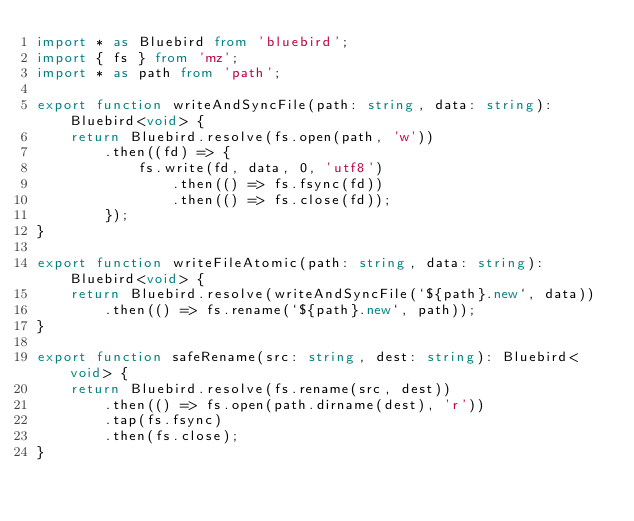Convert code to text. <code><loc_0><loc_0><loc_500><loc_500><_TypeScript_>import * as Bluebird from 'bluebird';
import { fs } from 'mz';
import * as path from 'path';

export function writeAndSyncFile(path: string, data: string): Bluebird<void> {
	return Bluebird.resolve(fs.open(path, 'w'))
		.then((fd) => {
			fs.write(fd, data, 0, 'utf8')
				.then(() => fs.fsync(fd))
				.then(() => fs.close(fd));
		});
}

export function writeFileAtomic(path: string, data: string): Bluebird<void> {
	return Bluebird.resolve(writeAndSyncFile(`${path}.new`, data))
		.then(() => fs.rename(`${path}.new`, path));
}

export function safeRename(src: string, dest: string): Bluebird<void> {
	return Bluebird.resolve(fs.rename(src, dest))
		.then(() => fs.open(path.dirname(dest), 'r'))
		.tap(fs.fsync)
		.then(fs.close);
}
</code> 